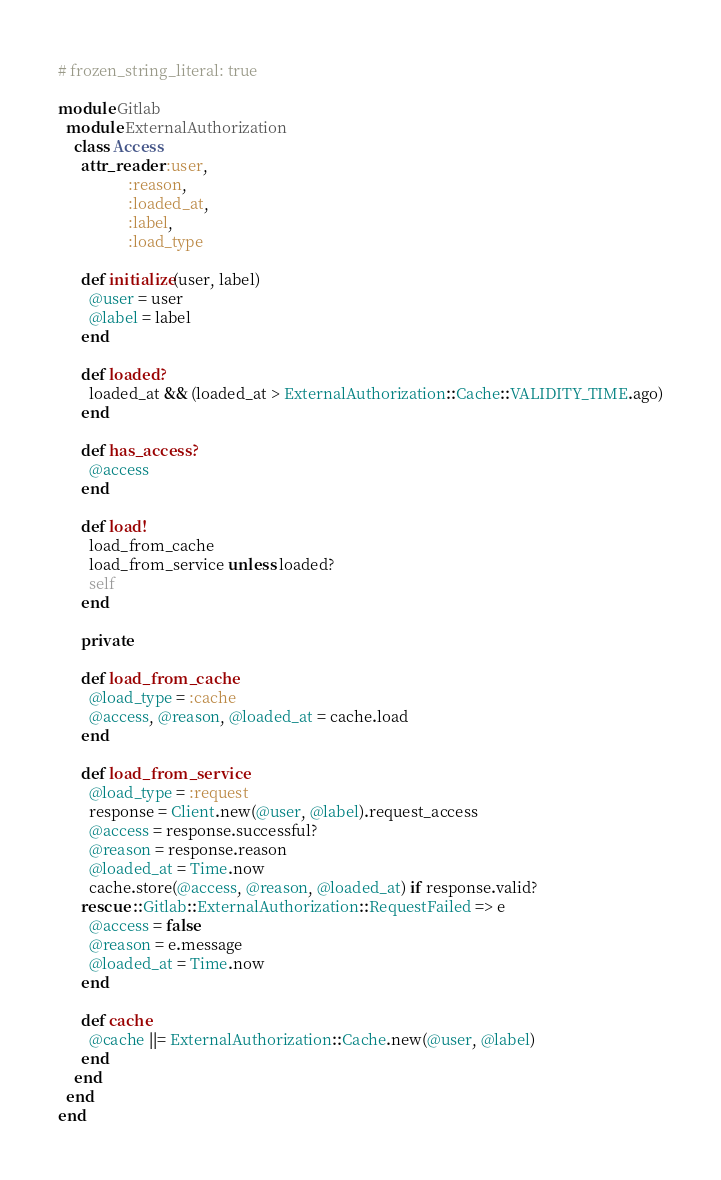<code> <loc_0><loc_0><loc_500><loc_500><_Ruby_># frozen_string_literal: true

module Gitlab
  module ExternalAuthorization
    class Access
      attr_reader :user,
                  :reason,
                  :loaded_at,
                  :label,
                  :load_type

      def initialize(user, label)
        @user = user
        @label = label
      end

      def loaded?
        loaded_at && (loaded_at > ExternalAuthorization::Cache::VALIDITY_TIME.ago)
      end

      def has_access?
        @access
      end

      def load!
        load_from_cache
        load_from_service unless loaded?
        self
      end

      private

      def load_from_cache
        @load_type = :cache
        @access, @reason, @loaded_at = cache.load
      end

      def load_from_service
        @load_type = :request
        response = Client.new(@user, @label).request_access
        @access = response.successful?
        @reason = response.reason
        @loaded_at = Time.now
        cache.store(@access, @reason, @loaded_at) if response.valid?
      rescue ::Gitlab::ExternalAuthorization::RequestFailed => e
        @access = false
        @reason = e.message
        @loaded_at = Time.now
      end

      def cache
        @cache ||= ExternalAuthorization::Cache.new(@user, @label)
      end
    end
  end
end
</code> 